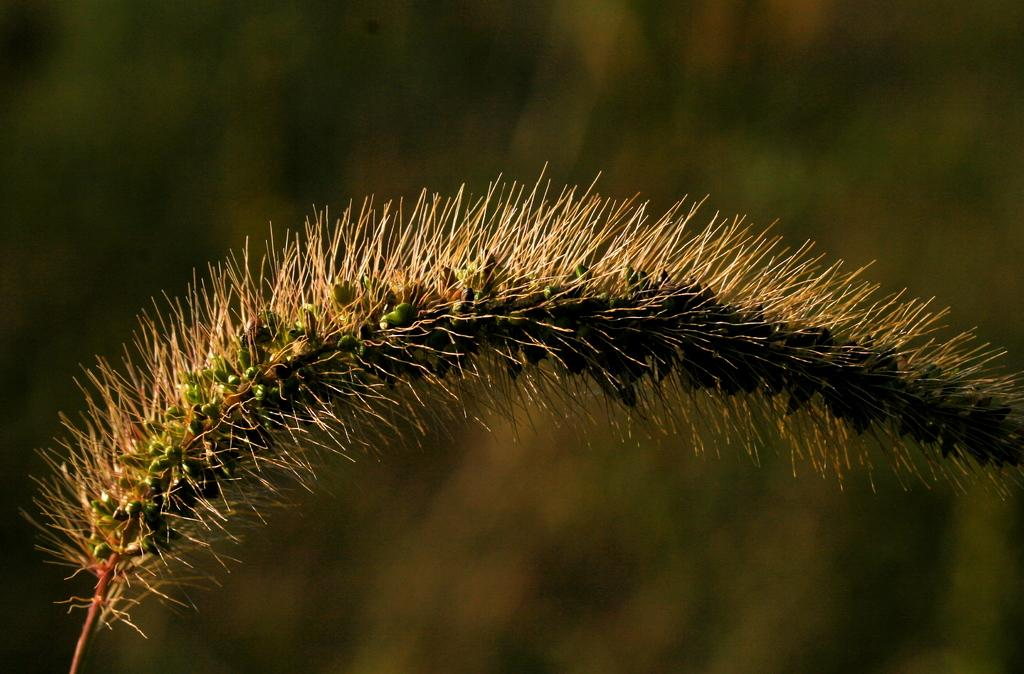What is present in the image? There is a plant in the image. Can you describe the background of the image? The background of the image is blurred. What type of poison is being used on the desk in the image? There is no desk or poison present in the image; it only features a plant with a blurred background. 